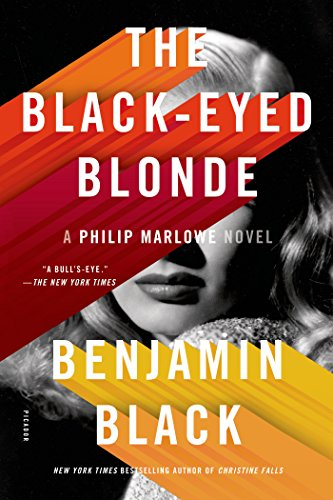Is this book related to Reference? No, this book is not categorized under the 'Reference' genre. It is a fictional novel that delves into mystery and suspense through its compelling narrative. 